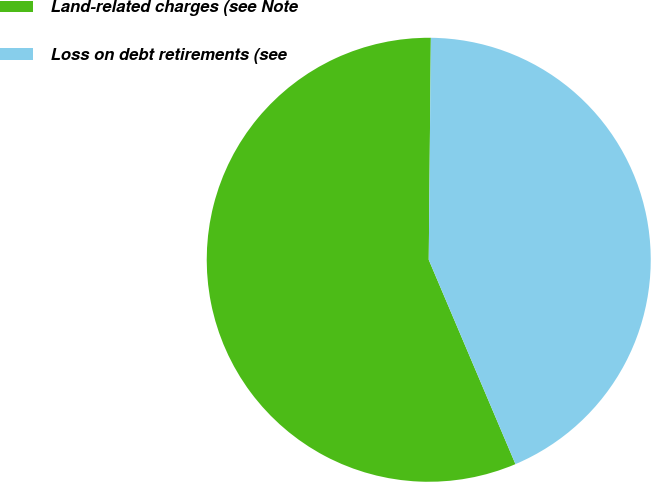Convert chart to OTSL. <chart><loc_0><loc_0><loc_500><loc_500><pie_chart><fcel>Land-related charges (see Note<fcel>Loss on debt retirements (see<nl><fcel>56.54%<fcel>43.46%<nl></chart> 